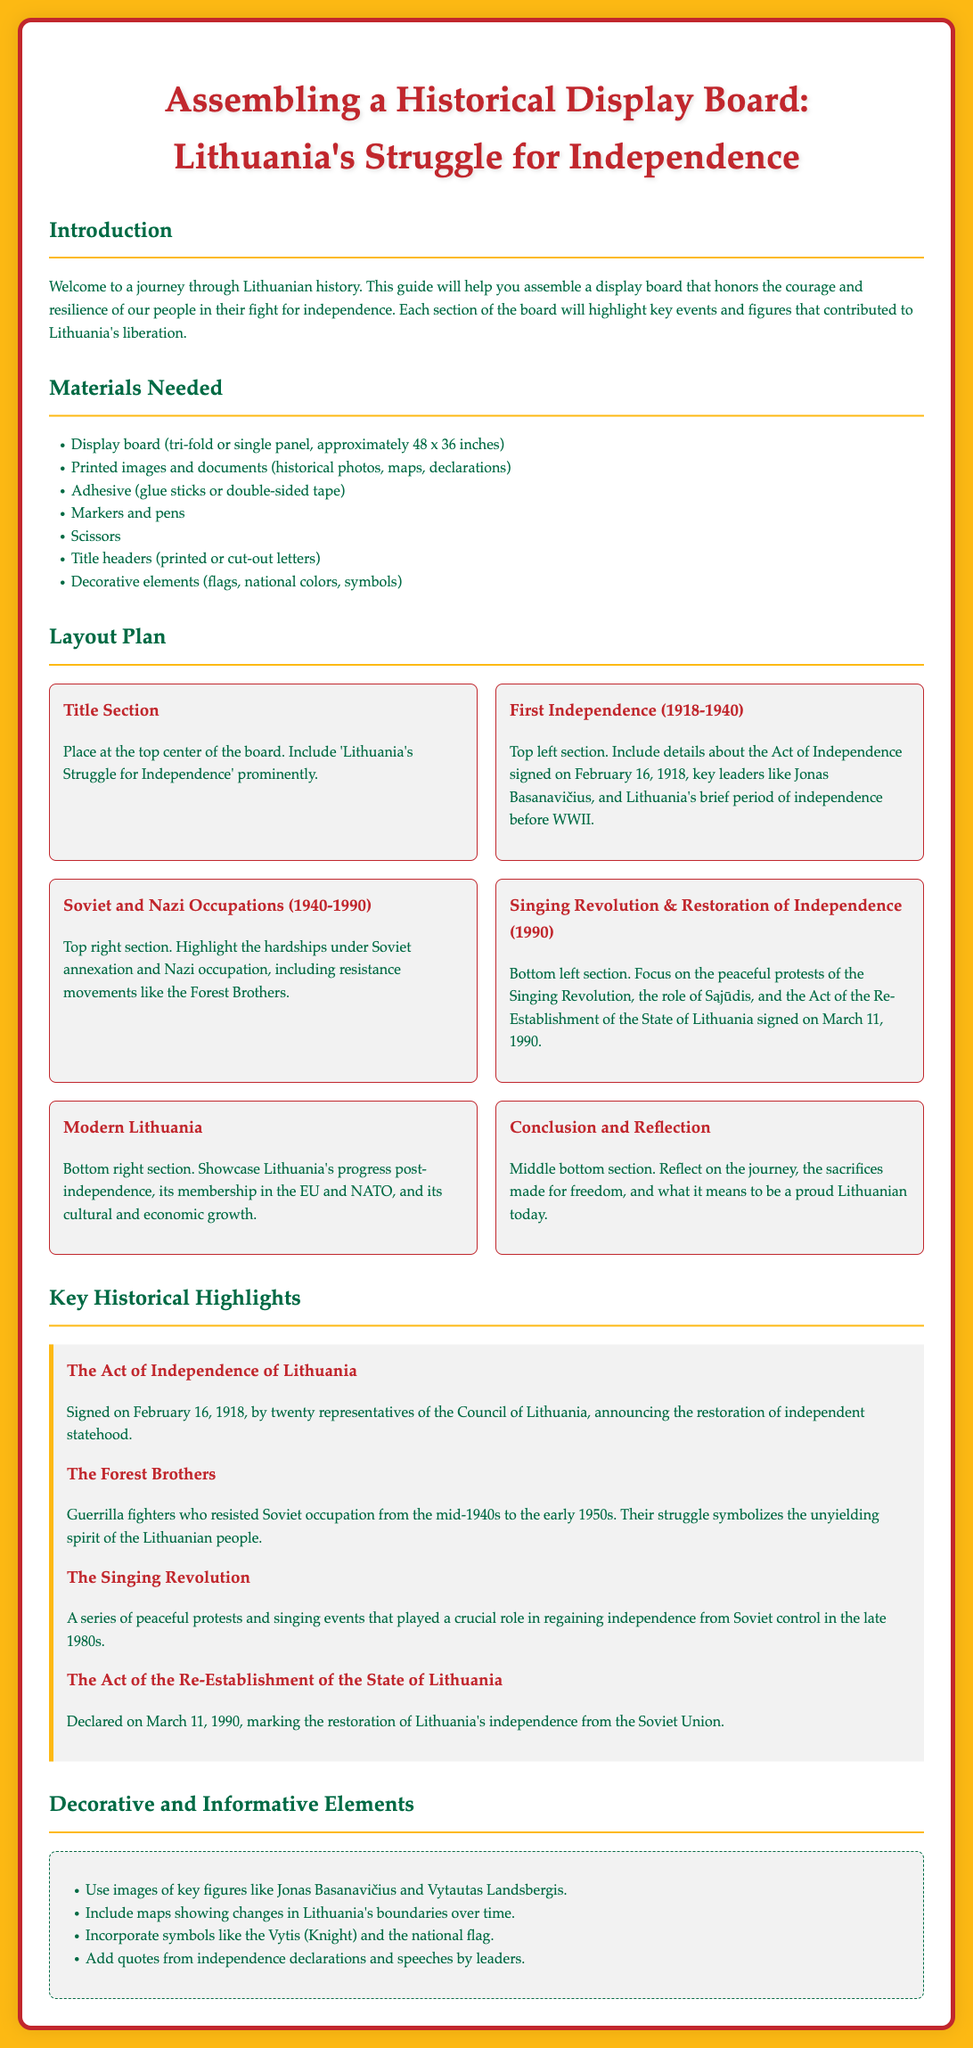What is the title of the display board? The title of the display board is prominently mentioned at the top center of the board, highlighting the theme of the assembly instructions.
Answer: Lithuania's Struggle for Independence When was the Act of Independence signed? The document specifies key events, and the date of the Act of Independence is clearly stated.
Answer: February 16, 1918 Who are the Forest Brothers? The document describes the Forest Brothers in relation to their historical significance in Lithuania's struggle against occupation.
Answer: Guerrilla fighters What does the bottom right section of the board showcase? By examining the layout plan, the content of the bottom right section is identifiable.
Answer: Modern Lithuania What color is the background of the document? The document describes the overall design, which includes the background color used throughout.
Answer: #FDB913 How many sections are there in the layout plan? By counting the sections referred to in the layout plan, the total number of sections is determined.
Answer: 6 What is one decorative element suggested for the board? The document lists decorative elements to enrich the display board, one of which can be identified.
Answer: Flags What significant event occurred on March 11, 1990? The document highlights important events, including a defining moment in Lithuania's history on this date.
Answer: Restoration of Independence 